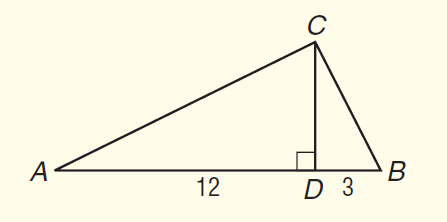Question: In \triangle A B C, C D is an altitude and m \angle A C B = 90. If A D = 12 and B D = 3, find A C to the nearest tenth.
Choices:
A. 6.5
B. 9.0
C. 13.4
D. 15.0
Answer with the letter. Answer: C 